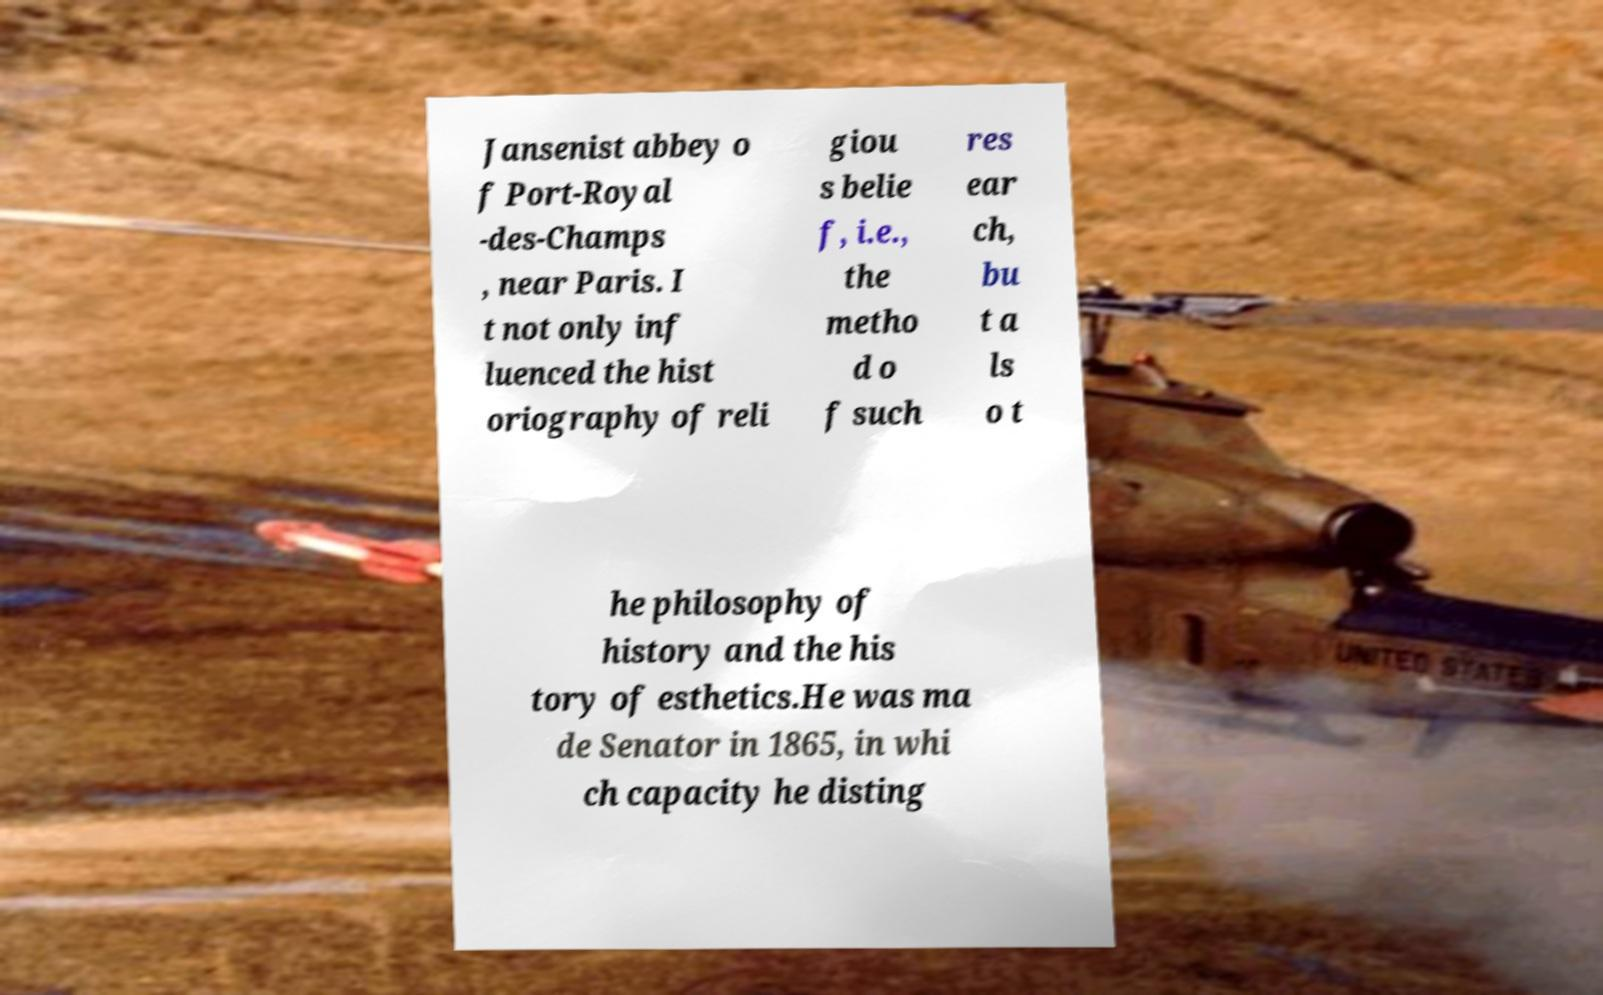For documentation purposes, I need the text within this image transcribed. Could you provide that? Jansenist abbey o f Port-Royal -des-Champs , near Paris. I t not only inf luenced the hist oriography of reli giou s belie f, i.e., the metho d o f such res ear ch, bu t a ls o t he philosophy of history and the his tory of esthetics.He was ma de Senator in 1865, in whi ch capacity he disting 